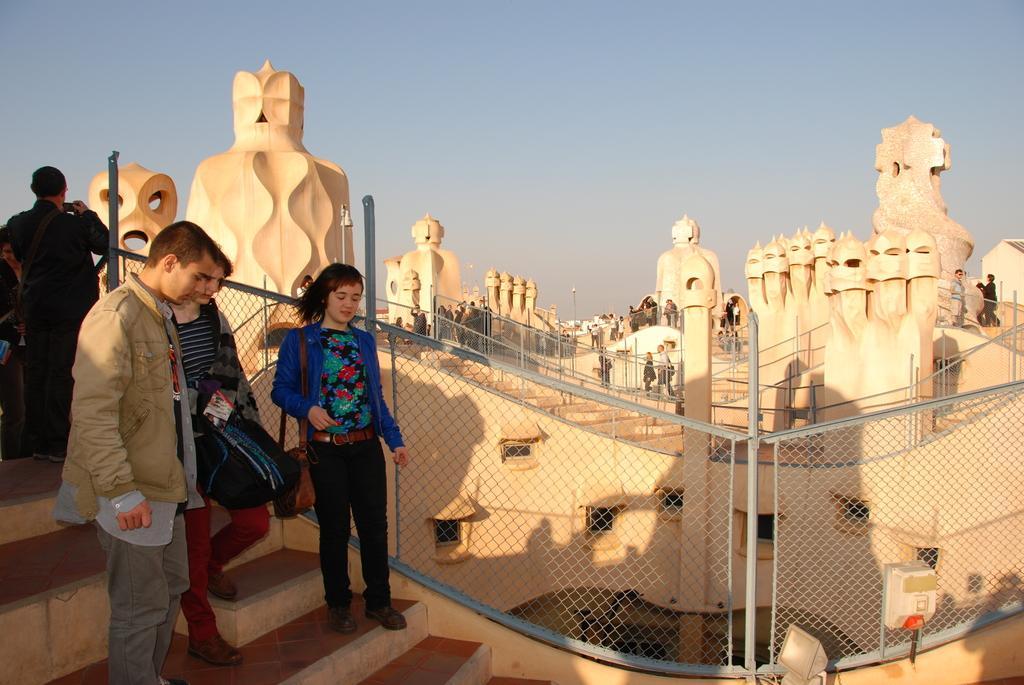Please provide a concise description of this image. This picture describes about group of people, in the background we can see few buildings, fence, metal rods and lights. 